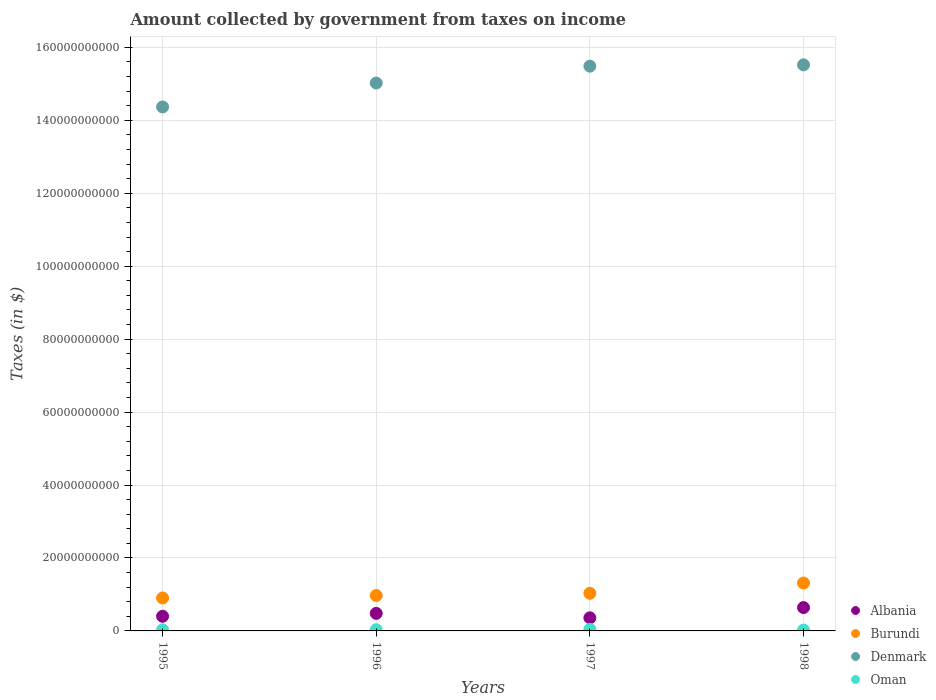How many different coloured dotlines are there?
Keep it short and to the point. 4. Is the number of dotlines equal to the number of legend labels?
Offer a very short reply. Yes. What is the amount collected by government from taxes on income in Denmark in 1998?
Your response must be concise. 1.55e+11. Across all years, what is the maximum amount collected by government from taxes on income in Oman?
Give a very brief answer. 4.31e+08. Across all years, what is the minimum amount collected by government from taxes on income in Oman?
Offer a terse response. 2.34e+08. In which year was the amount collected by government from taxes on income in Burundi maximum?
Give a very brief answer. 1998. In which year was the amount collected by government from taxes on income in Denmark minimum?
Make the answer very short. 1995. What is the total amount collected by government from taxes on income in Albania in the graph?
Provide a short and direct response. 1.88e+1. What is the difference between the amount collected by government from taxes on income in Denmark in 1996 and that in 1997?
Offer a terse response. -4.63e+09. What is the difference between the amount collected by government from taxes on income in Burundi in 1995 and the amount collected by government from taxes on income in Oman in 1996?
Make the answer very short. 8.70e+09. What is the average amount collected by government from taxes on income in Denmark per year?
Ensure brevity in your answer.  1.51e+11. In the year 1998, what is the difference between the amount collected by government from taxes on income in Albania and amount collected by government from taxes on income in Denmark?
Offer a terse response. -1.49e+11. In how many years, is the amount collected by government from taxes on income in Burundi greater than 28000000000 $?
Make the answer very short. 0. What is the ratio of the amount collected by government from taxes on income in Burundi in 1996 to that in 1998?
Your response must be concise. 0.74. What is the difference between the highest and the second highest amount collected by government from taxes on income in Oman?
Keep it short and to the point. 8.84e+07. What is the difference between the highest and the lowest amount collected by government from taxes on income in Oman?
Your response must be concise. 1.97e+08. In how many years, is the amount collected by government from taxes on income in Oman greater than the average amount collected by government from taxes on income in Oman taken over all years?
Offer a very short reply. 2. Is the sum of the amount collected by government from taxes on income in Oman in 1997 and 1998 greater than the maximum amount collected by government from taxes on income in Denmark across all years?
Provide a short and direct response. No. Is it the case that in every year, the sum of the amount collected by government from taxes on income in Oman and amount collected by government from taxes on income in Denmark  is greater than the amount collected by government from taxes on income in Albania?
Ensure brevity in your answer.  Yes. How many dotlines are there?
Make the answer very short. 4. How many years are there in the graph?
Provide a succinct answer. 4. What is the difference between two consecutive major ticks on the Y-axis?
Make the answer very short. 2.00e+1. Does the graph contain any zero values?
Keep it short and to the point. No. What is the title of the graph?
Provide a succinct answer. Amount collected by government from taxes on income. What is the label or title of the Y-axis?
Provide a succinct answer. Taxes (in $). What is the Taxes (in $) in Albania in 1995?
Your answer should be compact. 4.01e+09. What is the Taxes (in $) of Burundi in 1995?
Your response must be concise. 9.04e+09. What is the Taxes (in $) in Denmark in 1995?
Give a very brief answer. 1.44e+11. What is the Taxes (in $) in Oman in 1995?
Provide a short and direct response. 3.06e+08. What is the Taxes (in $) in Albania in 1996?
Provide a succinct answer. 4.81e+09. What is the Taxes (in $) in Burundi in 1996?
Your answer should be compact. 9.71e+09. What is the Taxes (in $) of Denmark in 1996?
Give a very brief answer. 1.50e+11. What is the Taxes (in $) in Oman in 1996?
Offer a terse response. 3.43e+08. What is the Taxes (in $) of Albania in 1997?
Provide a short and direct response. 3.59e+09. What is the Taxes (in $) of Burundi in 1997?
Your answer should be very brief. 1.03e+1. What is the Taxes (in $) of Denmark in 1997?
Offer a terse response. 1.55e+11. What is the Taxes (in $) of Oman in 1997?
Offer a terse response. 4.31e+08. What is the Taxes (in $) in Albania in 1998?
Your response must be concise. 6.40e+09. What is the Taxes (in $) in Burundi in 1998?
Provide a succinct answer. 1.31e+1. What is the Taxes (in $) of Denmark in 1998?
Your answer should be compact. 1.55e+11. What is the Taxes (in $) of Oman in 1998?
Offer a terse response. 2.34e+08. Across all years, what is the maximum Taxes (in $) in Albania?
Keep it short and to the point. 6.40e+09. Across all years, what is the maximum Taxes (in $) of Burundi?
Offer a very short reply. 1.31e+1. Across all years, what is the maximum Taxes (in $) of Denmark?
Offer a terse response. 1.55e+11. Across all years, what is the maximum Taxes (in $) in Oman?
Ensure brevity in your answer.  4.31e+08. Across all years, what is the minimum Taxes (in $) of Albania?
Your answer should be compact. 3.59e+09. Across all years, what is the minimum Taxes (in $) of Burundi?
Give a very brief answer. 9.04e+09. Across all years, what is the minimum Taxes (in $) in Denmark?
Ensure brevity in your answer.  1.44e+11. Across all years, what is the minimum Taxes (in $) in Oman?
Your answer should be very brief. 2.34e+08. What is the total Taxes (in $) in Albania in the graph?
Your answer should be compact. 1.88e+1. What is the total Taxes (in $) of Burundi in the graph?
Keep it short and to the point. 4.22e+1. What is the total Taxes (in $) in Denmark in the graph?
Provide a short and direct response. 6.04e+11. What is the total Taxes (in $) of Oman in the graph?
Your answer should be compact. 1.31e+09. What is the difference between the Taxes (in $) in Albania in 1995 and that in 1996?
Offer a very short reply. -7.94e+08. What is the difference between the Taxes (in $) of Burundi in 1995 and that in 1996?
Give a very brief answer. -6.73e+08. What is the difference between the Taxes (in $) of Denmark in 1995 and that in 1996?
Your answer should be compact. -6.56e+09. What is the difference between the Taxes (in $) in Oman in 1995 and that in 1996?
Offer a very short reply. -3.73e+07. What is the difference between the Taxes (in $) in Albania in 1995 and that in 1997?
Make the answer very short. 4.22e+08. What is the difference between the Taxes (in $) in Burundi in 1995 and that in 1997?
Make the answer very short. -1.28e+09. What is the difference between the Taxes (in $) of Denmark in 1995 and that in 1997?
Ensure brevity in your answer.  -1.12e+1. What is the difference between the Taxes (in $) in Oman in 1995 and that in 1997?
Provide a succinct answer. -1.26e+08. What is the difference between the Taxes (in $) of Albania in 1995 and that in 1998?
Keep it short and to the point. -2.39e+09. What is the difference between the Taxes (in $) in Burundi in 1995 and that in 1998?
Keep it short and to the point. -4.10e+09. What is the difference between the Taxes (in $) of Denmark in 1995 and that in 1998?
Provide a succinct answer. -1.16e+1. What is the difference between the Taxes (in $) of Oman in 1995 and that in 1998?
Your answer should be compact. 7.10e+07. What is the difference between the Taxes (in $) of Albania in 1996 and that in 1997?
Offer a terse response. 1.22e+09. What is the difference between the Taxes (in $) of Burundi in 1996 and that in 1997?
Your answer should be very brief. -6.10e+08. What is the difference between the Taxes (in $) of Denmark in 1996 and that in 1997?
Give a very brief answer. -4.63e+09. What is the difference between the Taxes (in $) in Oman in 1996 and that in 1997?
Give a very brief answer. -8.84e+07. What is the difference between the Taxes (in $) in Albania in 1996 and that in 1998?
Give a very brief answer. -1.59e+09. What is the difference between the Taxes (in $) in Burundi in 1996 and that in 1998?
Your response must be concise. -3.43e+09. What is the difference between the Taxes (in $) of Denmark in 1996 and that in 1998?
Provide a succinct answer. -4.99e+09. What is the difference between the Taxes (in $) in Oman in 1996 and that in 1998?
Your answer should be compact. 1.08e+08. What is the difference between the Taxes (in $) of Albania in 1997 and that in 1998?
Ensure brevity in your answer.  -2.81e+09. What is the difference between the Taxes (in $) of Burundi in 1997 and that in 1998?
Ensure brevity in your answer.  -2.82e+09. What is the difference between the Taxes (in $) of Denmark in 1997 and that in 1998?
Offer a very short reply. -3.65e+08. What is the difference between the Taxes (in $) in Oman in 1997 and that in 1998?
Offer a very short reply. 1.97e+08. What is the difference between the Taxes (in $) in Albania in 1995 and the Taxes (in $) in Burundi in 1996?
Your response must be concise. -5.70e+09. What is the difference between the Taxes (in $) in Albania in 1995 and the Taxes (in $) in Denmark in 1996?
Provide a short and direct response. -1.46e+11. What is the difference between the Taxes (in $) in Albania in 1995 and the Taxes (in $) in Oman in 1996?
Provide a short and direct response. 3.67e+09. What is the difference between the Taxes (in $) in Burundi in 1995 and the Taxes (in $) in Denmark in 1996?
Keep it short and to the point. -1.41e+11. What is the difference between the Taxes (in $) in Burundi in 1995 and the Taxes (in $) in Oman in 1996?
Ensure brevity in your answer.  8.70e+09. What is the difference between the Taxes (in $) of Denmark in 1995 and the Taxes (in $) of Oman in 1996?
Offer a very short reply. 1.43e+11. What is the difference between the Taxes (in $) of Albania in 1995 and the Taxes (in $) of Burundi in 1997?
Give a very brief answer. -6.31e+09. What is the difference between the Taxes (in $) in Albania in 1995 and the Taxes (in $) in Denmark in 1997?
Keep it short and to the point. -1.51e+11. What is the difference between the Taxes (in $) in Albania in 1995 and the Taxes (in $) in Oman in 1997?
Keep it short and to the point. 3.58e+09. What is the difference between the Taxes (in $) of Burundi in 1995 and the Taxes (in $) of Denmark in 1997?
Provide a succinct answer. -1.46e+11. What is the difference between the Taxes (in $) of Burundi in 1995 and the Taxes (in $) of Oman in 1997?
Keep it short and to the point. 8.61e+09. What is the difference between the Taxes (in $) of Denmark in 1995 and the Taxes (in $) of Oman in 1997?
Offer a terse response. 1.43e+11. What is the difference between the Taxes (in $) of Albania in 1995 and the Taxes (in $) of Burundi in 1998?
Make the answer very short. -9.13e+09. What is the difference between the Taxes (in $) of Albania in 1995 and the Taxes (in $) of Denmark in 1998?
Your answer should be very brief. -1.51e+11. What is the difference between the Taxes (in $) of Albania in 1995 and the Taxes (in $) of Oman in 1998?
Your answer should be very brief. 3.78e+09. What is the difference between the Taxes (in $) in Burundi in 1995 and the Taxes (in $) in Denmark in 1998?
Offer a very short reply. -1.46e+11. What is the difference between the Taxes (in $) of Burundi in 1995 and the Taxes (in $) of Oman in 1998?
Ensure brevity in your answer.  8.80e+09. What is the difference between the Taxes (in $) in Denmark in 1995 and the Taxes (in $) in Oman in 1998?
Give a very brief answer. 1.43e+11. What is the difference between the Taxes (in $) in Albania in 1996 and the Taxes (in $) in Burundi in 1997?
Make the answer very short. -5.51e+09. What is the difference between the Taxes (in $) in Albania in 1996 and the Taxes (in $) in Denmark in 1997?
Your response must be concise. -1.50e+11. What is the difference between the Taxes (in $) in Albania in 1996 and the Taxes (in $) in Oman in 1997?
Offer a terse response. 4.38e+09. What is the difference between the Taxes (in $) in Burundi in 1996 and the Taxes (in $) in Denmark in 1997?
Offer a terse response. -1.45e+11. What is the difference between the Taxes (in $) in Burundi in 1996 and the Taxes (in $) in Oman in 1997?
Your answer should be very brief. 9.28e+09. What is the difference between the Taxes (in $) in Denmark in 1996 and the Taxes (in $) in Oman in 1997?
Provide a succinct answer. 1.50e+11. What is the difference between the Taxes (in $) in Albania in 1996 and the Taxes (in $) in Burundi in 1998?
Provide a succinct answer. -8.33e+09. What is the difference between the Taxes (in $) of Albania in 1996 and the Taxes (in $) of Denmark in 1998?
Provide a short and direct response. -1.50e+11. What is the difference between the Taxes (in $) in Albania in 1996 and the Taxes (in $) in Oman in 1998?
Your answer should be compact. 4.57e+09. What is the difference between the Taxes (in $) of Burundi in 1996 and the Taxes (in $) of Denmark in 1998?
Your response must be concise. -1.46e+11. What is the difference between the Taxes (in $) in Burundi in 1996 and the Taxes (in $) in Oman in 1998?
Make the answer very short. 9.48e+09. What is the difference between the Taxes (in $) of Denmark in 1996 and the Taxes (in $) of Oman in 1998?
Provide a succinct answer. 1.50e+11. What is the difference between the Taxes (in $) in Albania in 1997 and the Taxes (in $) in Burundi in 1998?
Your answer should be compact. -9.55e+09. What is the difference between the Taxes (in $) in Albania in 1997 and the Taxes (in $) in Denmark in 1998?
Give a very brief answer. -1.52e+11. What is the difference between the Taxes (in $) in Albania in 1997 and the Taxes (in $) in Oman in 1998?
Provide a succinct answer. 3.36e+09. What is the difference between the Taxes (in $) of Burundi in 1997 and the Taxes (in $) of Denmark in 1998?
Offer a terse response. -1.45e+11. What is the difference between the Taxes (in $) of Burundi in 1997 and the Taxes (in $) of Oman in 1998?
Offer a terse response. 1.01e+1. What is the difference between the Taxes (in $) in Denmark in 1997 and the Taxes (in $) in Oman in 1998?
Your answer should be compact. 1.55e+11. What is the average Taxes (in $) in Albania per year?
Your answer should be very brief. 4.70e+09. What is the average Taxes (in $) in Burundi per year?
Your response must be concise. 1.06e+1. What is the average Taxes (in $) in Denmark per year?
Provide a succinct answer. 1.51e+11. What is the average Taxes (in $) in Oman per year?
Offer a terse response. 3.28e+08. In the year 1995, what is the difference between the Taxes (in $) of Albania and Taxes (in $) of Burundi?
Your response must be concise. -5.02e+09. In the year 1995, what is the difference between the Taxes (in $) of Albania and Taxes (in $) of Denmark?
Keep it short and to the point. -1.40e+11. In the year 1995, what is the difference between the Taxes (in $) of Albania and Taxes (in $) of Oman?
Keep it short and to the point. 3.71e+09. In the year 1995, what is the difference between the Taxes (in $) of Burundi and Taxes (in $) of Denmark?
Provide a short and direct response. -1.35e+11. In the year 1995, what is the difference between the Taxes (in $) in Burundi and Taxes (in $) in Oman?
Give a very brief answer. 8.73e+09. In the year 1995, what is the difference between the Taxes (in $) of Denmark and Taxes (in $) of Oman?
Offer a terse response. 1.43e+11. In the year 1996, what is the difference between the Taxes (in $) of Albania and Taxes (in $) of Burundi?
Provide a succinct answer. -4.90e+09. In the year 1996, what is the difference between the Taxes (in $) of Albania and Taxes (in $) of Denmark?
Provide a short and direct response. -1.45e+11. In the year 1996, what is the difference between the Taxes (in $) in Albania and Taxes (in $) in Oman?
Make the answer very short. 4.47e+09. In the year 1996, what is the difference between the Taxes (in $) of Burundi and Taxes (in $) of Denmark?
Your answer should be compact. -1.41e+11. In the year 1996, what is the difference between the Taxes (in $) in Burundi and Taxes (in $) in Oman?
Your response must be concise. 9.37e+09. In the year 1996, what is the difference between the Taxes (in $) of Denmark and Taxes (in $) of Oman?
Offer a terse response. 1.50e+11. In the year 1997, what is the difference between the Taxes (in $) in Albania and Taxes (in $) in Burundi?
Make the answer very short. -6.73e+09. In the year 1997, what is the difference between the Taxes (in $) in Albania and Taxes (in $) in Denmark?
Make the answer very short. -1.51e+11. In the year 1997, what is the difference between the Taxes (in $) in Albania and Taxes (in $) in Oman?
Give a very brief answer. 3.16e+09. In the year 1997, what is the difference between the Taxes (in $) of Burundi and Taxes (in $) of Denmark?
Offer a terse response. -1.45e+11. In the year 1997, what is the difference between the Taxes (in $) in Burundi and Taxes (in $) in Oman?
Keep it short and to the point. 9.89e+09. In the year 1997, what is the difference between the Taxes (in $) of Denmark and Taxes (in $) of Oman?
Provide a succinct answer. 1.54e+11. In the year 1998, what is the difference between the Taxes (in $) in Albania and Taxes (in $) in Burundi?
Provide a short and direct response. -6.74e+09. In the year 1998, what is the difference between the Taxes (in $) in Albania and Taxes (in $) in Denmark?
Provide a succinct answer. -1.49e+11. In the year 1998, what is the difference between the Taxes (in $) of Albania and Taxes (in $) of Oman?
Give a very brief answer. 6.17e+09. In the year 1998, what is the difference between the Taxes (in $) in Burundi and Taxes (in $) in Denmark?
Give a very brief answer. -1.42e+11. In the year 1998, what is the difference between the Taxes (in $) in Burundi and Taxes (in $) in Oman?
Your response must be concise. 1.29e+1. In the year 1998, what is the difference between the Taxes (in $) in Denmark and Taxes (in $) in Oman?
Provide a succinct answer. 1.55e+11. What is the ratio of the Taxes (in $) of Albania in 1995 to that in 1996?
Give a very brief answer. 0.83. What is the ratio of the Taxes (in $) in Burundi in 1995 to that in 1996?
Offer a terse response. 0.93. What is the ratio of the Taxes (in $) of Denmark in 1995 to that in 1996?
Your answer should be compact. 0.96. What is the ratio of the Taxes (in $) of Oman in 1995 to that in 1996?
Offer a terse response. 0.89. What is the ratio of the Taxes (in $) in Albania in 1995 to that in 1997?
Your response must be concise. 1.12. What is the ratio of the Taxes (in $) in Burundi in 1995 to that in 1997?
Provide a succinct answer. 0.88. What is the ratio of the Taxes (in $) of Denmark in 1995 to that in 1997?
Give a very brief answer. 0.93. What is the ratio of the Taxes (in $) of Oman in 1995 to that in 1997?
Give a very brief answer. 0.71. What is the ratio of the Taxes (in $) in Albania in 1995 to that in 1998?
Provide a succinct answer. 0.63. What is the ratio of the Taxes (in $) in Burundi in 1995 to that in 1998?
Your answer should be very brief. 0.69. What is the ratio of the Taxes (in $) of Denmark in 1995 to that in 1998?
Offer a terse response. 0.93. What is the ratio of the Taxes (in $) of Oman in 1995 to that in 1998?
Ensure brevity in your answer.  1.3. What is the ratio of the Taxes (in $) in Albania in 1996 to that in 1997?
Your answer should be compact. 1.34. What is the ratio of the Taxes (in $) in Burundi in 1996 to that in 1997?
Your response must be concise. 0.94. What is the ratio of the Taxes (in $) of Denmark in 1996 to that in 1997?
Ensure brevity in your answer.  0.97. What is the ratio of the Taxes (in $) in Oman in 1996 to that in 1997?
Your answer should be very brief. 0.8. What is the ratio of the Taxes (in $) of Albania in 1996 to that in 1998?
Offer a terse response. 0.75. What is the ratio of the Taxes (in $) of Burundi in 1996 to that in 1998?
Ensure brevity in your answer.  0.74. What is the ratio of the Taxes (in $) in Denmark in 1996 to that in 1998?
Ensure brevity in your answer.  0.97. What is the ratio of the Taxes (in $) of Oman in 1996 to that in 1998?
Offer a terse response. 1.46. What is the ratio of the Taxes (in $) in Albania in 1997 to that in 1998?
Ensure brevity in your answer.  0.56. What is the ratio of the Taxes (in $) in Burundi in 1997 to that in 1998?
Provide a short and direct response. 0.79. What is the ratio of the Taxes (in $) in Denmark in 1997 to that in 1998?
Offer a terse response. 1. What is the ratio of the Taxes (in $) of Oman in 1997 to that in 1998?
Your answer should be compact. 1.84. What is the difference between the highest and the second highest Taxes (in $) of Albania?
Provide a short and direct response. 1.59e+09. What is the difference between the highest and the second highest Taxes (in $) of Burundi?
Give a very brief answer. 2.82e+09. What is the difference between the highest and the second highest Taxes (in $) in Denmark?
Offer a very short reply. 3.65e+08. What is the difference between the highest and the second highest Taxes (in $) in Oman?
Offer a terse response. 8.84e+07. What is the difference between the highest and the lowest Taxes (in $) of Albania?
Your answer should be very brief. 2.81e+09. What is the difference between the highest and the lowest Taxes (in $) of Burundi?
Offer a very short reply. 4.10e+09. What is the difference between the highest and the lowest Taxes (in $) of Denmark?
Your response must be concise. 1.16e+1. What is the difference between the highest and the lowest Taxes (in $) of Oman?
Ensure brevity in your answer.  1.97e+08. 